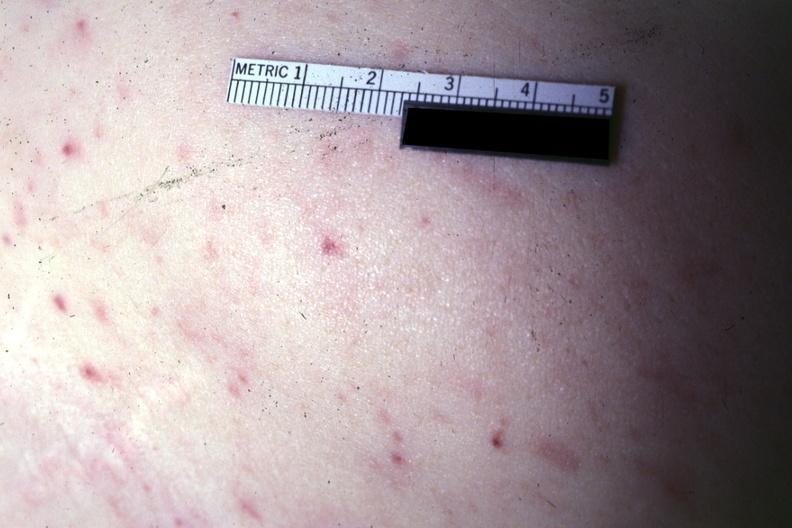s petechiae present?
Answer the question using a single word or phrase. Yes 